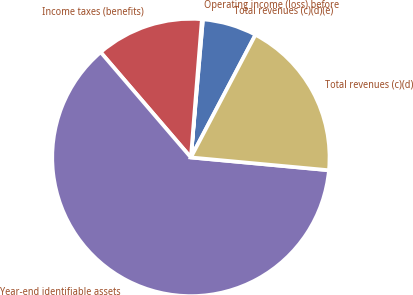Convert chart. <chart><loc_0><loc_0><loc_500><loc_500><pie_chart><fcel>Total revenues (c)(d)(e)<fcel>Operating income (loss) before<fcel>Income taxes (benefits)<fcel>Year-end identifiable assets<fcel>Total revenues (c)(d)<nl><fcel>6.33%<fcel>0.12%<fcel>12.54%<fcel>62.25%<fcel>18.76%<nl></chart> 